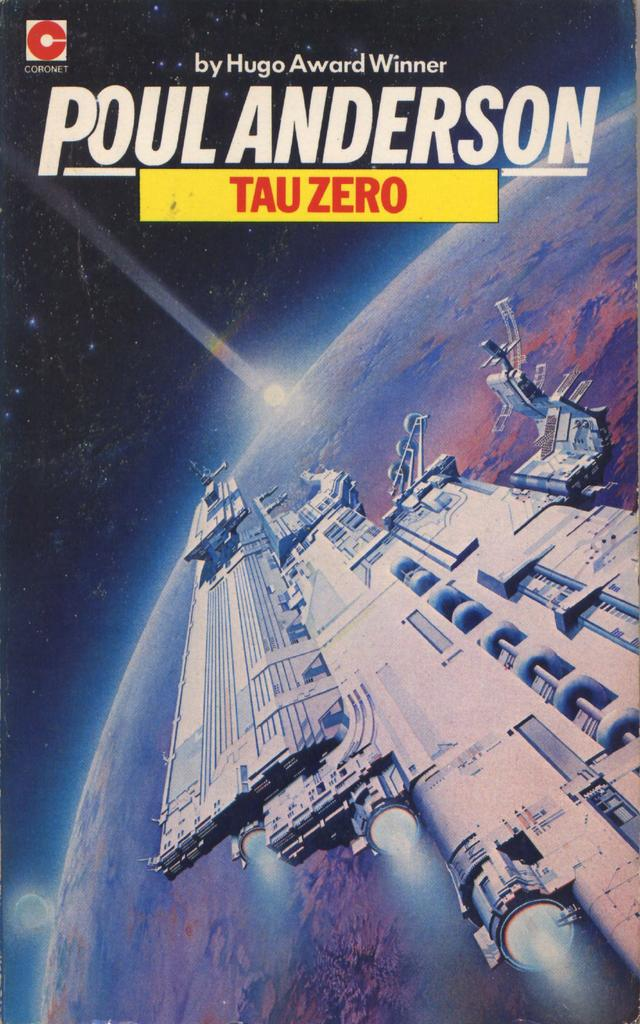What is the main subject of the poster in the image? The poster appears to depict a satellite. What other celestial object is visible in the image? A planet is visible in the image. Can you describe the lighting in the image? There is a light in the image. What is written on the top of the image? There is some matter written on the top of the image. What news is being reported by the hand in the image? There is no hand present in the image, and therefore no news being reported. 